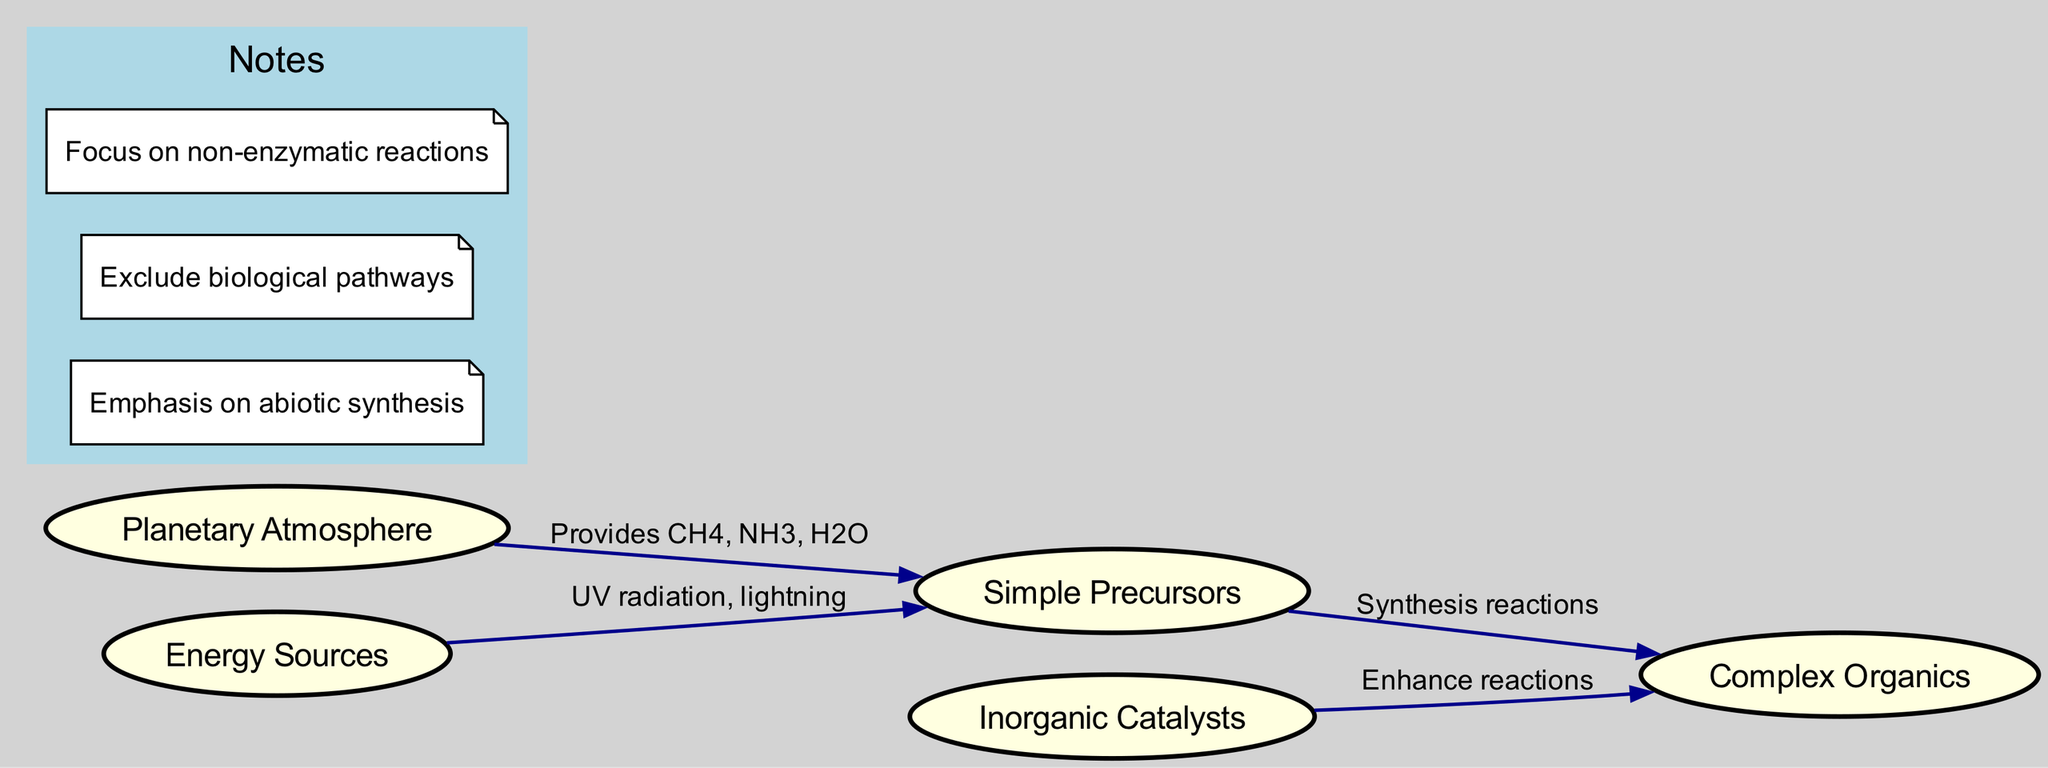What is the central node in the diagram? The central theme of the diagram is the "Planetary Atmosphere," which is positioned as the primary node. This node connects various elements regarding chemical processes occurring in such atmospheres.
Answer: Planetary Atmosphere How many nodes are in the diagram? By counting the individual nodes presented, we find there are five nodes: "Planetary Atmosphere," "Energy Sources," "Simple Precursors," "Complex Organics," and "Inorganic Catalysts."
Answer: 5 What energy sources are identified in the diagram? The diagram shows "UV radiation" and "lightning" as the specific energy sources linked to the "Simple Precursors."
Answer: UV radiation, lightning What is the label of the edge connecting 'Simple Precursors' and 'Complex Organics'? The edge that connects these two nodes indicates the processes involved in transforming simple components into more complex forms, labeled "Synthesis reactions."
Answer: Synthesis reactions What enhances the reactions leading to organic molecule formation? The diagram illustrates that "Inorganic Catalysts" serve to enhance the reactions that produce complex organics from simpler precursors, indicating their crucial role in these chemical processes.
Answer: Inorganic Catalysts Which node provides chemical compounds like CH4, NH3, and H2O? The "Planetary Atmosphere" node is responsible for providing these essential chemical precursors, as depicted in the diagram's connections.
Answer: Planetary Atmosphere What type of synthesis is emphasized in the notes? The notes specifically highlight that the focus is on "abiotic synthesis," which translates to non-biological processes for organic molecule formation, thereby excluding biological pathways.
Answer: abiotic synthesis Identify one requirement for the chemical processes represented in the diagram. The diagram notes that it emphasizes "non-enzymatic reactions," indicating a focus on chemical processes that do not involve biological enzymes.
Answer: non-enzymatic reactions How do "Energy Sources" relate to "Simple Precursors"? The relationship between these nodes is established by the edge marked with "UV radiation, lightning," which indicates that these energy sources influence the formation of simple precursors.
Answer: UV radiation, lightning 